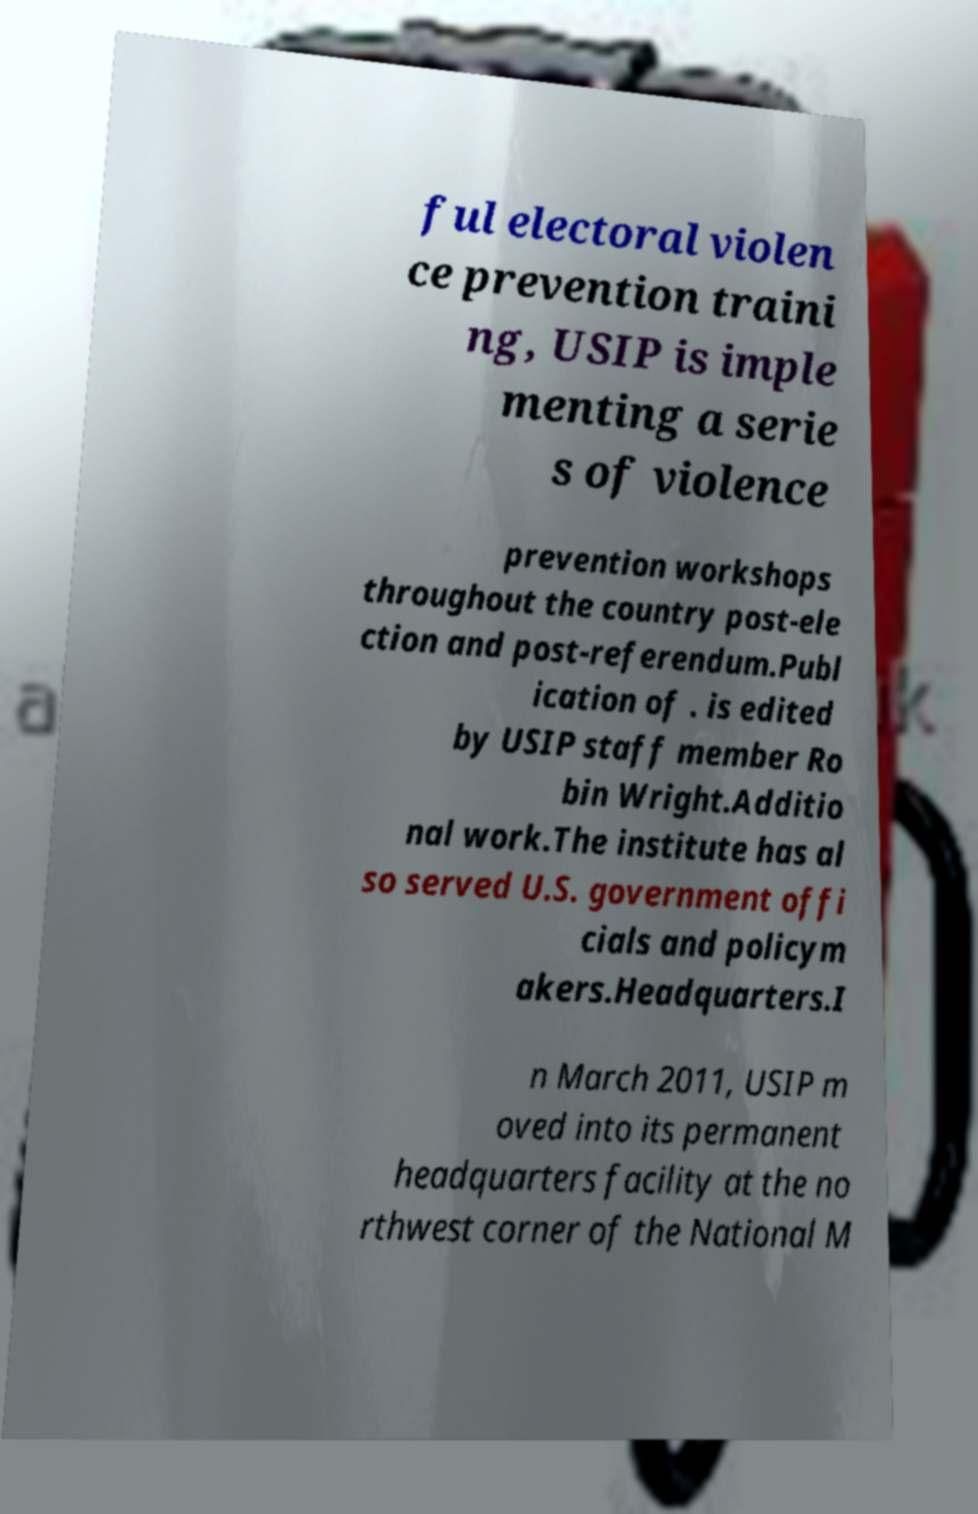Please identify and transcribe the text found in this image. ful electoral violen ce prevention traini ng, USIP is imple menting a serie s of violence prevention workshops throughout the country post-ele ction and post-referendum.Publ ication of . is edited by USIP staff member Ro bin Wright.Additio nal work.The institute has al so served U.S. government offi cials and policym akers.Headquarters.I n March 2011, USIP m oved into its permanent headquarters facility at the no rthwest corner of the National M 